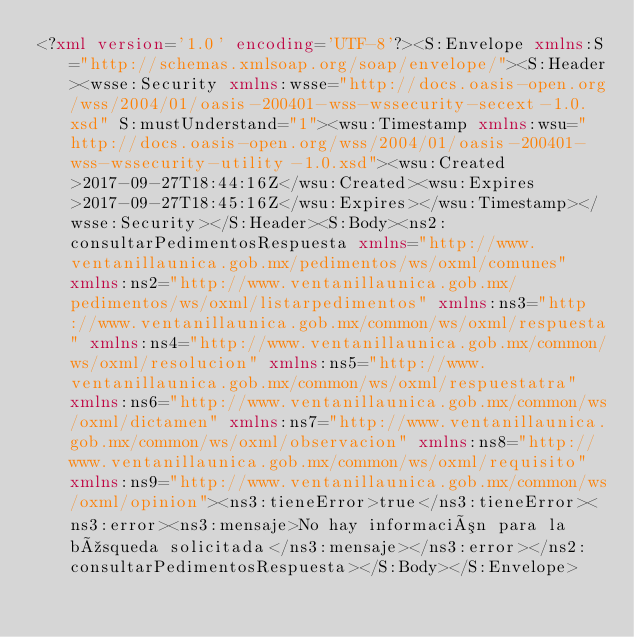<code> <loc_0><loc_0><loc_500><loc_500><_XML_><?xml version='1.0' encoding='UTF-8'?><S:Envelope xmlns:S="http://schemas.xmlsoap.org/soap/envelope/"><S:Header><wsse:Security xmlns:wsse="http://docs.oasis-open.org/wss/2004/01/oasis-200401-wss-wssecurity-secext-1.0.xsd" S:mustUnderstand="1"><wsu:Timestamp xmlns:wsu="http://docs.oasis-open.org/wss/2004/01/oasis-200401-wss-wssecurity-utility-1.0.xsd"><wsu:Created>2017-09-27T18:44:16Z</wsu:Created><wsu:Expires>2017-09-27T18:45:16Z</wsu:Expires></wsu:Timestamp></wsse:Security></S:Header><S:Body><ns2:consultarPedimentosRespuesta xmlns="http://www.ventanillaunica.gob.mx/pedimentos/ws/oxml/comunes" xmlns:ns2="http://www.ventanillaunica.gob.mx/pedimentos/ws/oxml/listarpedimentos" xmlns:ns3="http://www.ventanillaunica.gob.mx/common/ws/oxml/respuesta" xmlns:ns4="http://www.ventanillaunica.gob.mx/common/ws/oxml/resolucion" xmlns:ns5="http://www.ventanillaunica.gob.mx/common/ws/oxml/respuestatra" xmlns:ns6="http://www.ventanillaunica.gob.mx/common/ws/oxml/dictamen" xmlns:ns7="http://www.ventanillaunica.gob.mx/common/ws/oxml/observacion" xmlns:ns8="http://www.ventanillaunica.gob.mx/common/ws/oxml/requisito" xmlns:ns9="http://www.ventanillaunica.gob.mx/common/ws/oxml/opinion"><ns3:tieneError>true</ns3:tieneError><ns3:error><ns3:mensaje>No hay información para la búsqueda solicitada</ns3:mensaje></ns3:error></ns2:consultarPedimentosRespuesta></S:Body></S:Envelope></code> 